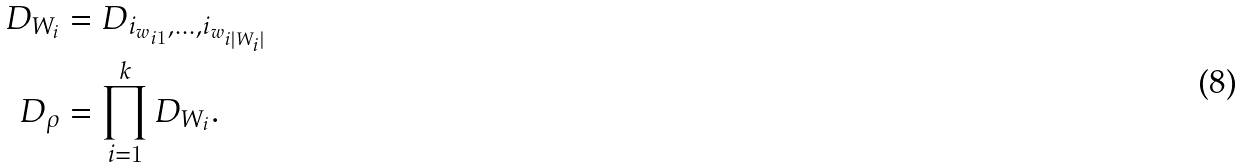<formula> <loc_0><loc_0><loc_500><loc_500>D _ { W _ { i } } & = D _ { i _ { w _ { i 1 } } , \dots , i _ { w _ { i | W _ { i } | } } } \\ D _ { \rho } & = \prod _ { i = 1 } ^ { k } D _ { W _ { i } } .</formula> 